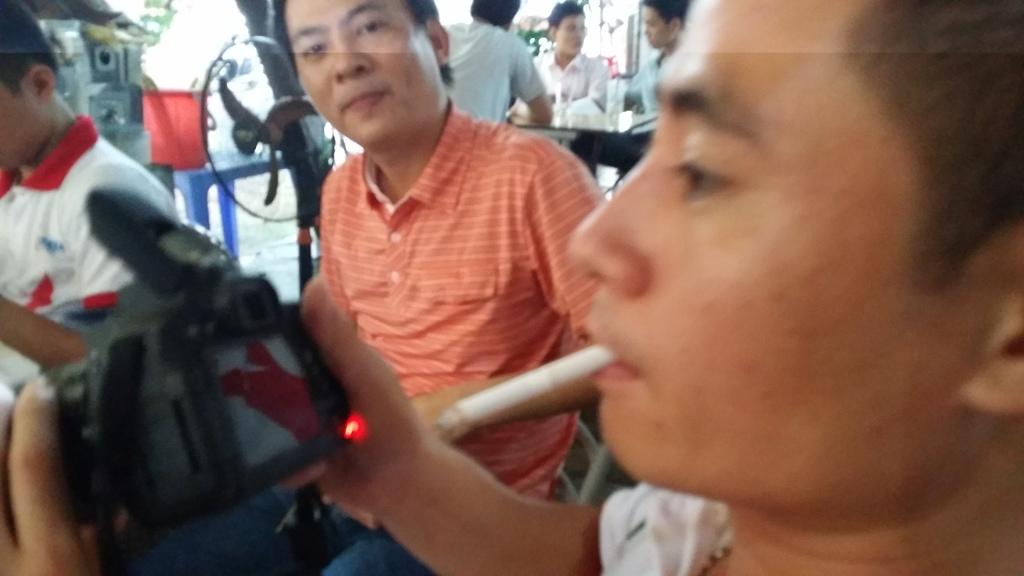What is the main subject of the image? There is a man in the image. What is the man doing in the image? The man has a cigarette in his mouth and is holding a camera in his hands. Can you describe the background of the image? There are people in the background of the image, and there is a table fan visible as well. How many fairies are visible in the image? There are no fairies present in the image. What is the distance between the man and the floor in the image? The image does not provide enough information to determine the distance between the man and the floor. 